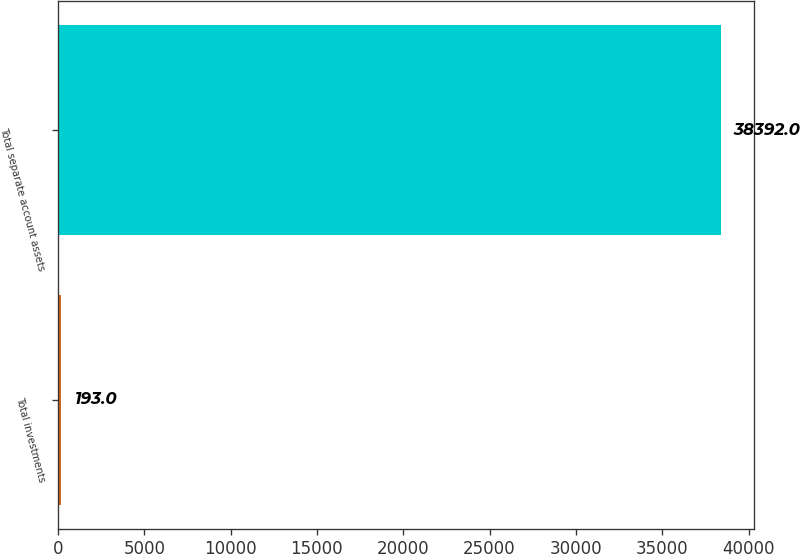Convert chart to OTSL. <chart><loc_0><loc_0><loc_500><loc_500><bar_chart><fcel>Total investments<fcel>Total separate account assets<nl><fcel>193<fcel>38392<nl></chart> 